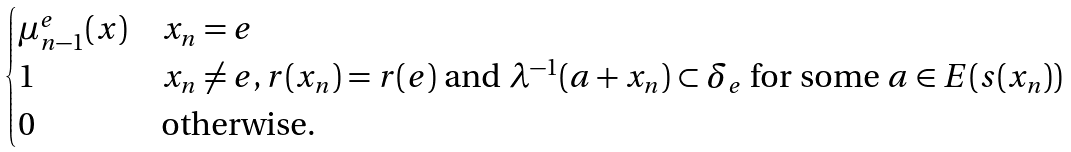Convert formula to latex. <formula><loc_0><loc_0><loc_500><loc_500>\begin{cases} \mu ^ { e } _ { n - 1 } ( x ) & x _ { n } = e \\ 1 & x _ { n } \neq e , r ( x _ { n } ) = r ( e ) \text { and } \lambda ^ { - 1 } ( a + x _ { n } ) \subset \delta _ { e } \text { for some } a \in E ( s ( x _ { n } ) ) \\ 0 & \text {otherwise} . \end{cases}</formula> 